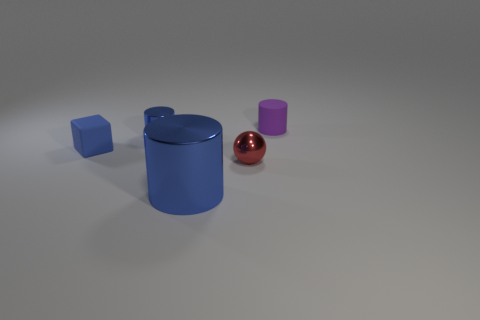The blue shiny thing that is the same size as the sphere is what shape?
Give a very brief answer. Cylinder. How many other objects are the same color as the large cylinder?
Ensure brevity in your answer.  2. What is the shape of the small object that is both to the left of the purple rubber object and behind the tiny cube?
Your response must be concise. Cylinder. There is a blue shiny object that is behind the red ball that is in front of the small purple object; is there a tiny matte object right of it?
Make the answer very short. Yes. How many other things are there of the same material as the purple thing?
Give a very brief answer. 1. What number of blue shiny blocks are there?
Give a very brief answer. 0. What number of things are small metal balls or cylinders right of the tiny blue metal object?
Offer a terse response. 3. Is there anything else that has the same shape as the blue matte object?
Offer a terse response. No. Do the blue cylinder that is in front of the red metal sphere and the red thing have the same size?
Provide a succinct answer. No. What number of metal things are small blue objects or spheres?
Provide a succinct answer. 2. 